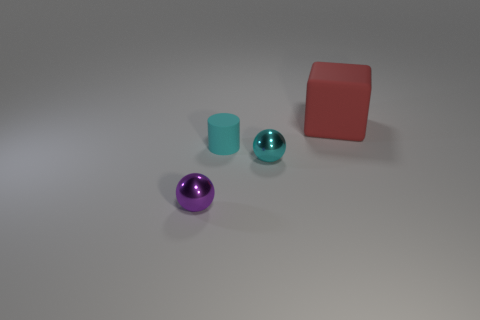Add 1 tiny purple rubber things. How many objects exist? 5 Subtract all cylinders. How many objects are left? 3 Subtract all cyan spheres. Subtract all blue cubes. How many spheres are left? 1 Subtract all big metal spheres. Subtract all cyan rubber things. How many objects are left? 3 Add 4 red cubes. How many red cubes are left? 5 Add 4 cyan metallic objects. How many cyan metallic objects exist? 5 Subtract 0 brown cubes. How many objects are left? 4 